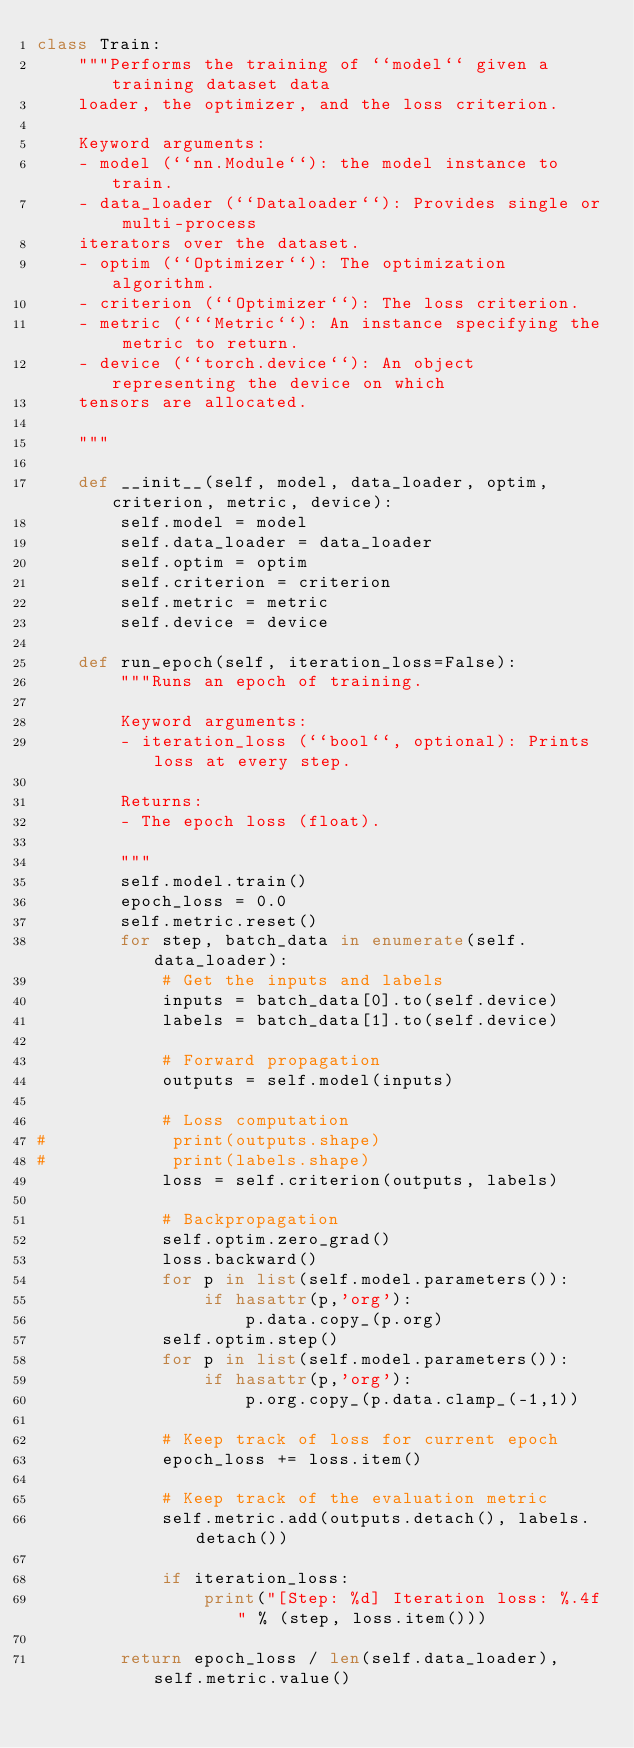Convert code to text. <code><loc_0><loc_0><loc_500><loc_500><_Python_>class Train:
    """Performs the training of ``model`` given a training dataset data
    loader, the optimizer, and the loss criterion.

    Keyword arguments:
    - model (``nn.Module``): the model instance to train.
    - data_loader (``Dataloader``): Provides single or multi-process
    iterators over the dataset.
    - optim (``Optimizer``): The optimization algorithm.
    - criterion (``Optimizer``): The loss criterion.
    - metric (```Metric``): An instance specifying the metric to return.
    - device (``torch.device``): An object representing the device on which
    tensors are allocated.

    """

    def __init__(self, model, data_loader, optim, criterion, metric, device):
        self.model = model
        self.data_loader = data_loader
        self.optim = optim
        self.criterion = criterion
        self.metric = metric
        self.device = device

    def run_epoch(self, iteration_loss=False):
        """Runs an epoch of training.

        Keyword arguments:
        - iteration_loss (``bool``, optional): Prints loss at every step.

        Returns:
        - The epoch loss (float).

        """
        self.model.train()
        epoch_loss = 0.0
        self.metric.reset()
        for step, batch_data in enumerate(self.data_loader):
            # Get the inputs and labels
            inputs = batch_data[0].to(self.device)
            labels = batch_data[1].to(self.device)

            # Forward propagation
            outputs = self.model(inputs)

            # Loss computation
#            print(outputs.shape)
#            print(labels.shape)
            loss = self.criterion(outputs, labels)

            # Backpropagation
            self.optim.zero_grad()
            loss.backward()
            for p in list(self.model.parameters()):
                if hasattr(p,'org'):
                    p.data.copy_(p.org)
            self.optim.step()
            for p in list(self.model.parameters()):
                if hasattr(p,'org'):
                    p.org.copy_(p.data.clamp_(-1,1))

            # Keep track of loss for current epoch
            epoch_loss += loss.item()

            # Keep track of the evaluation metric
            self.metric.add(outputs.detach(), labels.detach())

            if iteration_loss:
                print("[Step: %d] Iteration loss: %.4f" % (step, loss.item()))

        return epoch_loss / len(self.data_loader), self.metric.value()
</code> 